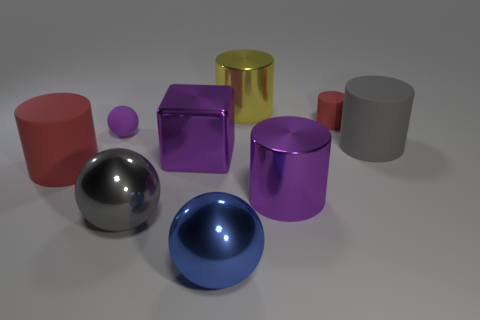Subtract all yellow cylinders. How many cylinders are left? 4 Subtract all purple metallic cylinders. How many cylinders are left? 4 Subtract all blue cylinders. Subtract all red cubes. How many cylinders are left? 5 Add 1 large gray balls. How many objects exist? 10 Subtract all cylinders. How many objects are left? 4 Add 9 big red rubber cylinders. How many big red rubber cylinders are left? 10 Add 2 purple cylinders. How many purple cylinders exist? 3 Subtract 0 cyan cylinders. How many objects are left? 9 Subtract all blue balls. Subtract all big gray rubber cylinders. How many objects are left? 7 